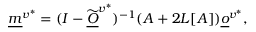<formula> <loc_0><loc_0><loc_500><loc_500>\underline { m } ^ { v ^ { * } } = ( I - \widetilde { \underline { O } } ^ { v ^ { * } } ) ^ { - 1 } ( A + 2 L [ A ] ) \underline { o } ^ { v ^ { * } } ,</formula> 